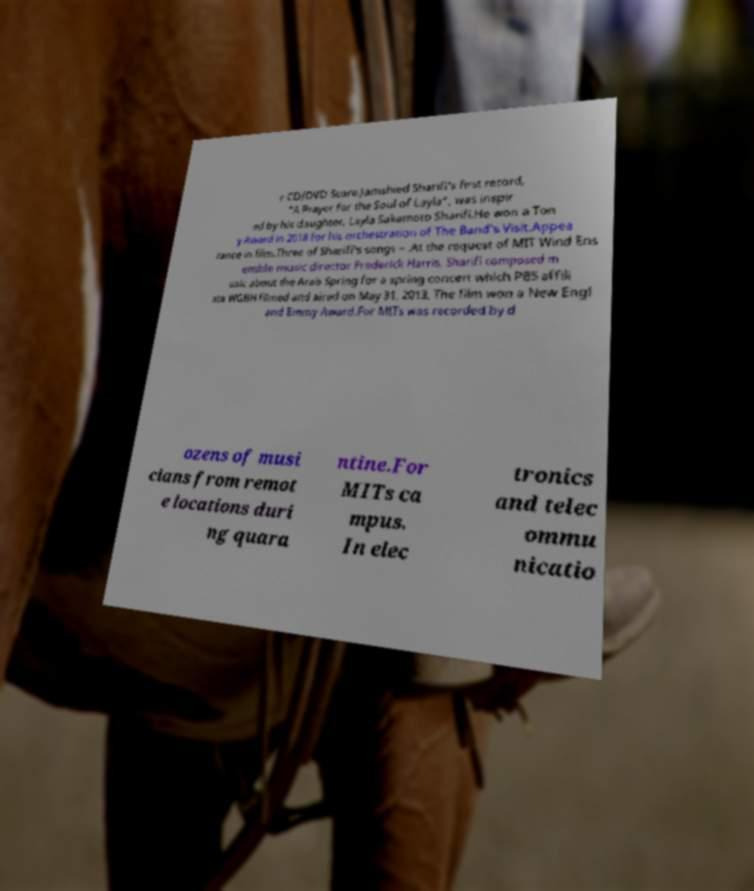Could you extract and type out the text from this image? r CD/DVD Score.Jamshied Sharifi's first record, "A Prayer for the Soul of Layla", was inspir ed by his daughter, Layla Sakamoto Sharifi.He won a Ton y Award in 2018 for his orchestration of The Band's Visit.Appea rance in film.Three of Sharifi's songs – .At the request of MIT Wind Ens emble music director Frederick Harris, Sharifi composed m usic about the Arab Spring for a spring concert which PBS affili ate WGBH filmed and aired on May 31, 2013. The film won a New Engl and Emmy Award.For MITs was recorded by d ozens of musi cians from remot e locations duri ng quara ntine.For MITs ca mpus. In elec tronics and telec ommu nicatio 